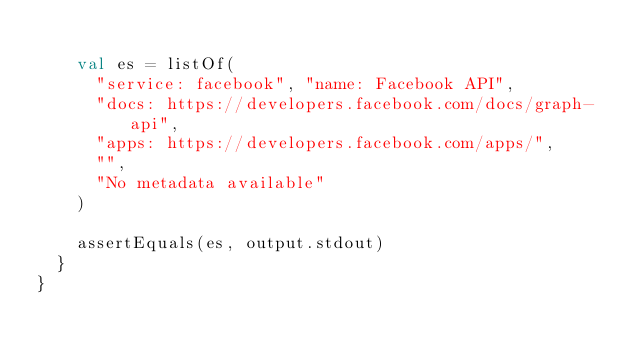Convert code to text. <code><loc_0><loc_0><loc_500><loc_500><_Kotlin_>
    val es = listOf(
      "service: facebook", "name: Facebook API",
      "docs: https://developers.facebook.com/docs/graph-api",
      "apps: https://developers.facebook.com/apps/",
      "",
      "No metadata available"
    )

    assertEquals(es, output.stdout)
  }
}
</code> 